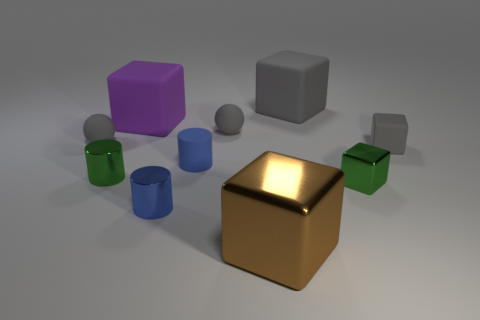Subtract 2 blocks. How many blocks are left? 3 Subtract all purple blocks. How many blocks are left? 4 Subtract all big metallic cubes. How many cubes are left? 4 Subtract all red blocks. Subtract all yellow spheres. How many blocks are left? 5 Subtract all balls. How many objects are left? 8 Subtract all large yellow matte spheres. Subtract all small rubber spheres. How many objects are left? 8 Add 7 brown blocks. How many brown blocks are left? 8 Add 6 gray spheres. How many gray spheres exist? 8 Subtract 1 green blocks. How many objects are left? 9 